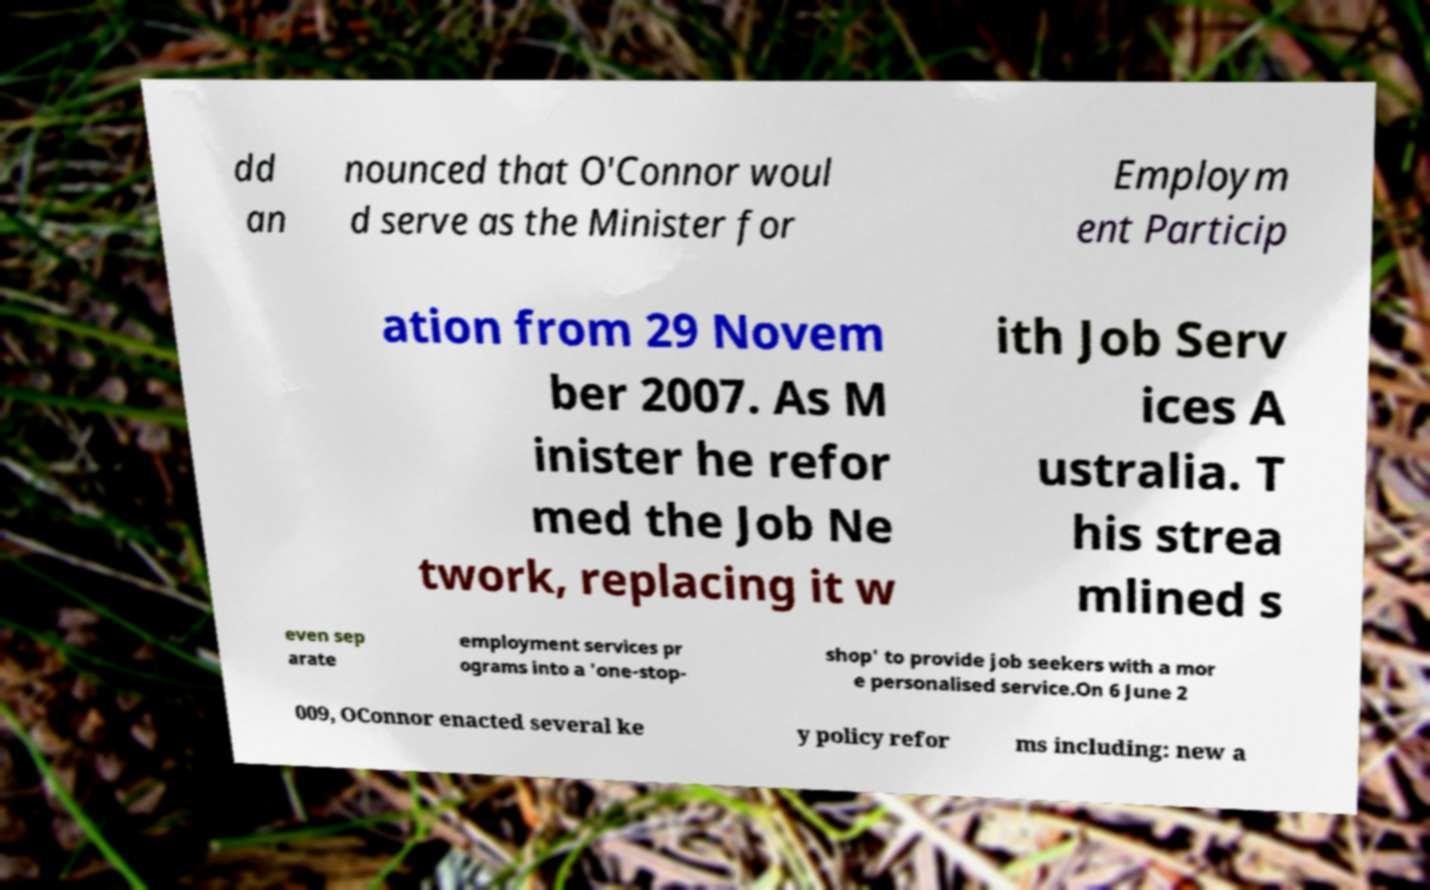Can you accurately transcribe the text from the provided image for me? dd an nounced that O'Connor woul d serve as the Minister for Employm ent Particip ation from 29 Novem ber 2007. As M inister he refor med the Job Ne twork, replacing it w ith Job Serv ices A ustralia. T his strea mlined s even sep arate employment services pr ograms into a 'one-stop- shop' to provide job seekers with a mor e personalised service.On 6 June 2 009, OConnor enacted several ke y policy refor ms including: new a 